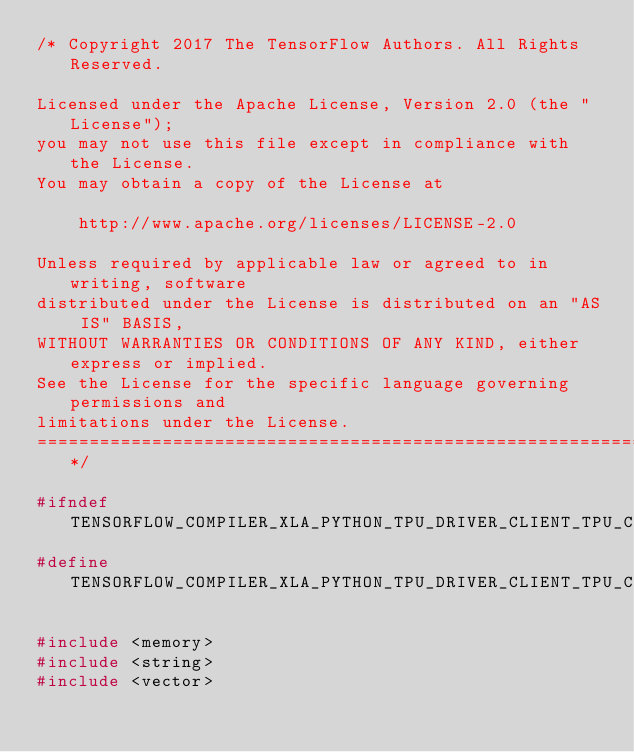<code> <loc_0><loc_0><loc_500><loc_500><_C_>/* Copyright 2017 The TensorFlow Authors. All Rights Reserved.

Licensed under the Apache License, Version 2.0 (the "License");
you may not use this file except in compliance with the License.
You may obtain a copy of the License at

    http://www.apache.org/licenses/LICENSE-2.0

Unless required by applicable law or agreed to in writing, software
distributed under the License is distributed on an "AS IS" BASIS,
WITHOUT WARRANTIES OR CONDITIONS OF ANY KIND, either express or implied.
See the License for the specific language governing permissions and
limitations under the License.
==============================================================================*/

#ifndef TENSORFLOW_COMPILER_XLA_PYTHON_TPU_DRIVER_CLIENT_TPU_CLIENT_H_
#define TENSORFLOW_COMPILER_XLA_PYTHON_TPU_DRIVER_CLIENT_TPU_CLIENT_H_

#include <memory>
#include <string>
#include <vector>
</code> 